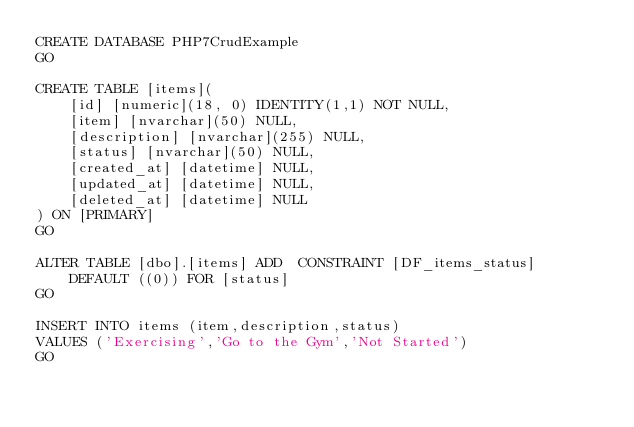<code> <loc_0><loc_0><loc_500><loc_500><_SQL_>CREATE DATABASE PHP7CrudExample
GO

CREATE TABLE [items](
    [id] [numeric](18, 0) IDENTITY(1,1) NOT NULL,
    [item] [nvarchar](50) NULL,
    [description] [nvarchar](255) NULL,
    [status] [nvarchar](50) NULL,
    [created_at] [datetime] NULL,
    [updated_at] [datetime] NULL,
    [deleted_at] [datetime] NULL
) ON [PRIMARY]
GO

ALTER TABLE [dbo].[items] ADD  CONSTRAINT [DF_items_status]  DEFAULT ((0)) FOR [status]
GO

INSERT INTO items (item,description,status)
VALUES ('Exercising','Go to the Gym','Not Started')
GO
</code> 